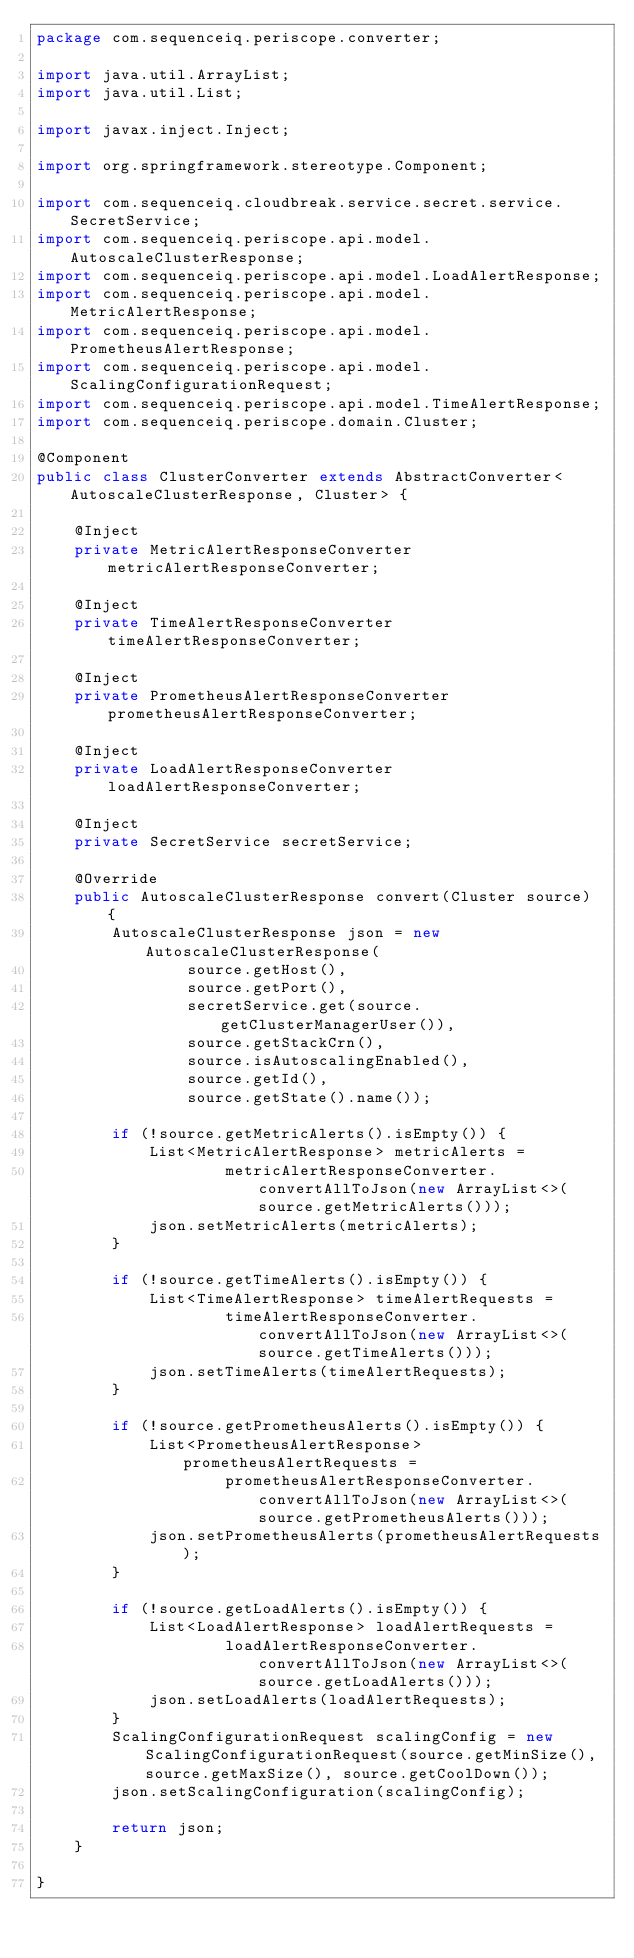<code> <loc_0><loc_0><loc_500><loc_500><_Java_>package com.sequenceiq.periscope.converter;

import java.util.ArrayList;
import java.util.List;

import javax.inject.Inject;

import org.springframework.stereotype.Component;

import com.sequenceiq.cloudbreak.service.secret.service.SecretService;
import com.sequenceiq.periscope.api.model.AutoscaleClusterResponse;
import com.sequenceiq.periscope.api.model.LoadAlertResponse;
import com.sequenceiq.periscope.api.model.MetricAlertResponse;
import com.sequenceiq.periscope.api.model.PrometheusAlertResponse;
import com.sequenceiq.periscope.api.model.ScalingConfigurationRequest;
import com.sequenceiq.periscope.api.model.TimeAlertResponse;
import com.sequenceiq.periscope.domain.Cluster;

@Component
public class ClusterConverter extends AbstractConverter<AutoscaleClusterResponse, Cluster> {

    @Inject
    private MetricAlertResponseConverter metricAlertResponseConverter;

    @Inject
    private TimeAlertResponseConverter timeAlertResponseConverter;

    @Inject
    private PrometheusAlertResponseConverter prometheusAlertResponseConverter;

    @Inject
    private LoadAlertResponseConverter loadAlertResponseConverter;

    @Inject
    private SecretService secretService;

    @Override
    public AutoscaleClusterResponse convert(Cluster source) {
        AutoscaleClusterResponse json = new AutoscaleClusterResponse(
                source.getHost(),
                source.getPort(),
                secretService.get(source.getClusterManagerUser()),
                source.getStackCrn(),
                source.isAutoscalingEnabled(),
                source.getId(),
                source.getState().name());

        if (!source.getMetricAlerts().isEmpty()) {
            List<MetricAlertResponse> metricAlerts =
                    metricAlertResponseConverter.convertAllToJson(new ArrayList<>(source.getMetricAlerts()));
            json.setMetricAlerts(metricAlerts);
        }

        if (!source.getTimeAlerts().isEmpty()) {
            List<TimeAlertResponse> timeAlertRequests =
                    timeAlertResponseConverter.convertAllToJson(new ArrayList<>(source.getTimeAlerts()));
            json.setTimeAlerts(timeAlertRequests);
        }

        if (!source.getPrometheusAlerts().isEmpty()) {
            List<PrometheusAlertResponse> prometheusAlertRequests =
                    prometheusAlertResponseConverter.convertAllToJson(new ArrayList<>(source.getPrometheusAlerts()));
            json.setPrometheusAlerts(prometheusAlertRequests);
        }

        if (!source.getLoadAlerts().isEmpty()) {
            List<LoadAlertResponse> loadAlertRequests =
                    loadAlertResponseConverter.convertAllToJson(new ArrayList<>(source.getLoadAlerts()));
            json.setLoadAlerts(loadAlertRequests);
        }
        ScalingConfigurationRequest scalingConfig = new ScalingConfigurationRequest(source.getMinSize(), source.getMaxSize(), source.getCoolDown());
        json.setScalingConfiguration(scalingConfig);

        return json;
    }

}
</code> 